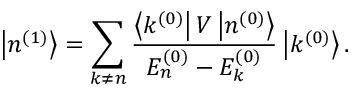<formula> <loc_0><loc_0><loc_500><loc_500>\left | n ^ { ( 1 ) } \right \rangle = \sum _ { k \neq n } { \frac { \left \langle k ^ { ( 0 ) } \right | V \left | n ^ { ( 0 ) } \right \rangle } { E _ { n } ^ { ( 0 ) } - E _ { k } ^ { ( 0 ) } } } \left | k ^ { ( 0 ) } \right \rangle .</formula> 